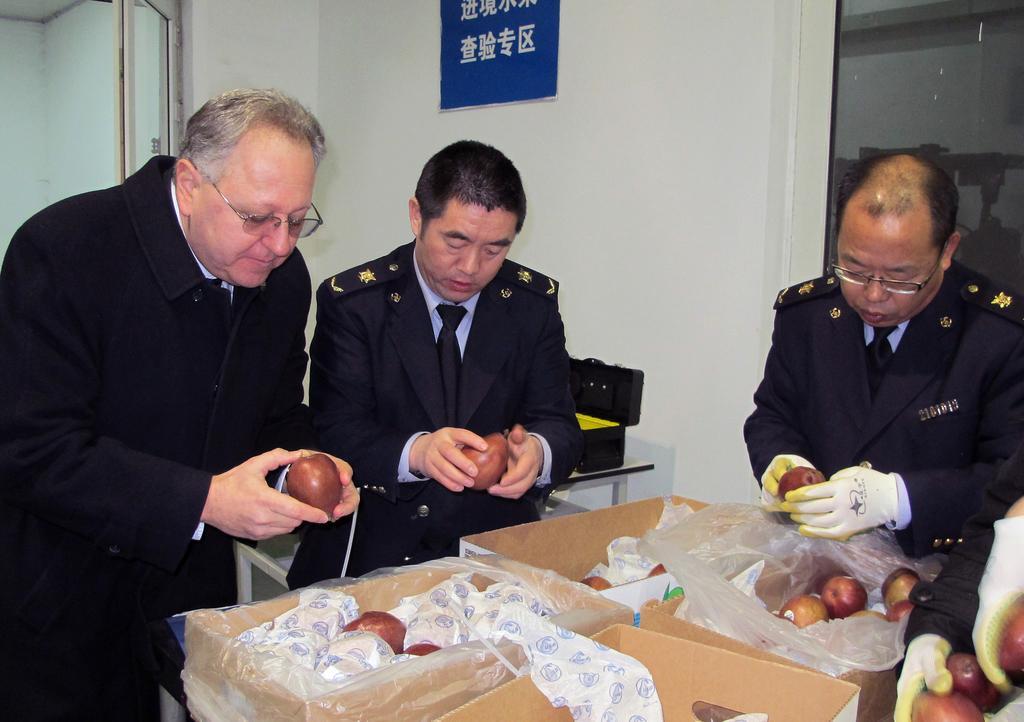Could you give a brief overview of what you see in this image? In the center of the image three mans are standing and holding an apple in there hands. At the bottom of the image we can see boxes, apples, paper, cover are present. At the top of the image wall and a board are there. On the left side of the image door is present. 